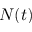<formula> <loc_0><loc_0><loc_500><loc_500>N ( t )</formula> 